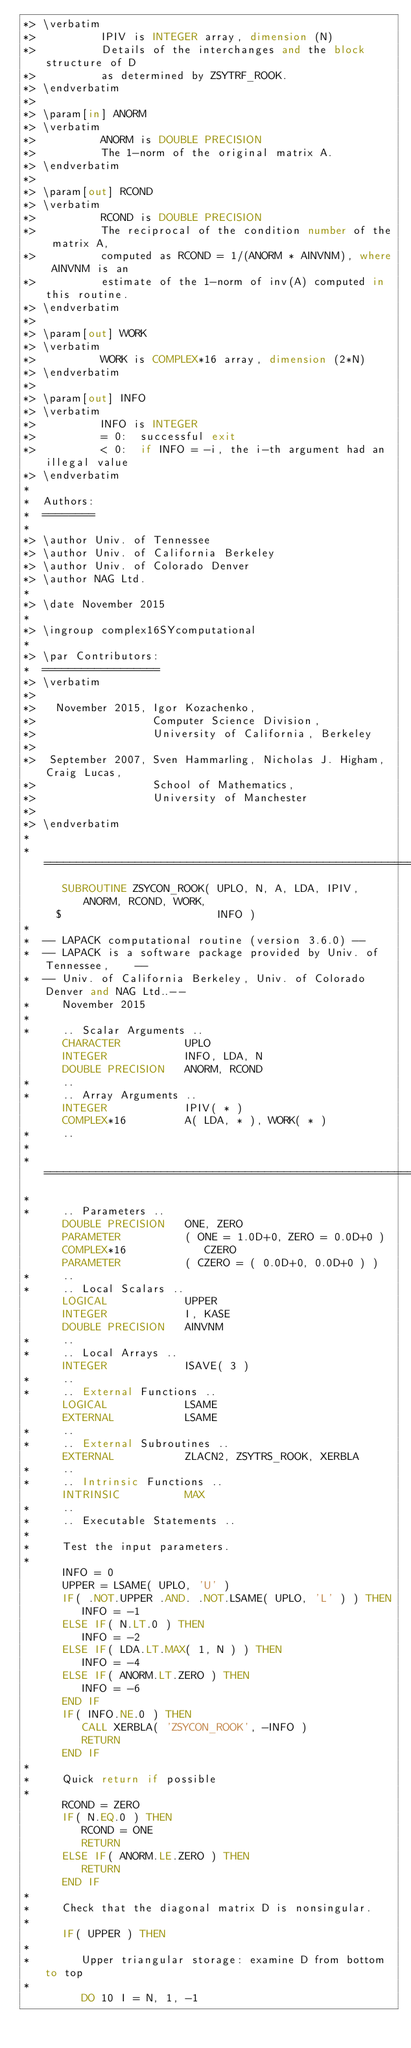<code> <loc_0><loc_0><loc_500><loc_500><_FORTRAN_>*> \verbatim
*>          IPIV is INTEGER array, dimension (N)
*>          Details of the interchanges and the block structure of D
*>          as determined by ZSYTRF_ROOK.
*> \endverbatim
*>
*> \param[in] ANORM
*> \verbatim
*>          ANORM is DOUBLE PRECISION
*>          The 1-norm of the original matrix A.
*> \endverbatim
*>
*> \param[out] RCOND
*> \verbatim
*>          RCOND is DOUBLE PRECISION
*>          The reciprocal of the condition number of the matrix A,
*>          computed as RCOND = 1/(ANORM * AINVNM), where AINVNM is an
*>          estimate of the 1-norm of inv(A) computed in this routine.
*> \endverbatim
*>
*> \param[out] WORK
*> \verbatim
*>          WORK is COMPLEX*16 array, dimension (2*N)
*> \endverbatim
*>
*> \param[out] INFO
*> \verbatim
*>          INFO is INTEGER
*>          = 0:  successful exit
*>          < 0:  if INFO = -i, the i-th argument had an illegal value
*> \endverbatim
*
*  Authors:
*  ========
*
*> \author Univ. of Tennessee 
*> \author Univ. of California Berkeley 
*> \author Univ. of Colorado Denver 
*> \author NAG Ltd. 
*
*> \date November 2015
*
*> \ingroup complex16SYcomputational
*
*> \par Contributors:
*  ==================
*> \verbatim
*>
*>   November 2015, Igor Kozachenko,
*>                  Computer Science Division,
*>                  University of California, Berkeley
*>
*>  September 2007, Sven Hammarling, Nicholas J. Higham, Craig Lucas,
*>                  School of Mathematics,
*>                  University of Manchester
*>
*> \endverbatim
*
*  =====================================================================
      SUBROUTINE ZSYCON_ROOK( UPLO, N, A, LDA, IPIV, ANORM, RCOND, WORK,
     $                        INFO )
*
*  -- LAPACK computational routine (version 3.6.0) --
*  -- LAPACK is a software package provided by Univ. of Tennessee,    --
*  -- Univ. of California Berkeley, Univ. of Colorado Denver and NAG Ltd..--
*     November 2015
*
*     .. Scalar Arguments ..
      CHARACTER          UPLO
      INTEGER            INFO, LDA, N
      DOUBLE PRECISION   ANORM, RCOND
*     ..
*     .. Array Arguments ..
      INTEGER            IPIV( * )
      COMPLEX*16         A( LDA, * ), WORK( * )
*     ..
*
*  =====================================================================
*
*     .. Parameters ..
      DOUBLE PRECISION   ONE, ZERO
      PARAMETER          ( ONE = 1.0D+0, ZERO = 0.0D+0 )
      COMPLEX*16            CZERO
      PARAMETER          ( CZERO = ( 0.0D+0, 0.0D+0 ) )
*     ..
*     .. Local Scalars ..
      LOGICAL            UPPER
      INTEGER            I, KASE
      DOUBLE PRECISION   AINVNM
*     ..
*     .. Local Arrays ..
      INTEGER            ISAVE( 3 )
*     ..
*     .. External Functions ..
      LOGICAL            LSAME
      EXTERNAL           LSAME
*     ..
*     .. External Subroutines ..
      EXTERNAL           ZLACN2, ZSYTRS_ROOK, XERBLA
*     ..
*     .. Intrinsic Functions ..
      INTRINSIC          MAX
*     ..
*     .. Executable Statements ..
*
*     Test the input parameters.
*
      INFO = 0
      UPPER = LSAME( UPLO, 'U' )
      IF( .NOT.UPPER .AND. .NOT.LSAME( UPLO, 'L' ) ) THEN
         INFO = -1
      ELSE IF( N.LT.0 ) THEN
         INFO = -2
      ELSE IF( LDA.LT.MAX( 1, N ) ) THEN
         INFO = -4
      ELSE IF( ANORM.LT.ZERO ) THEN
         INFO = -6
      END IF
      IF( INFO.NE.0 ) THEN
         CALL XERBLA( 'ZSYCON_ROOK', -INFO )
         RETURN
      END IF
*
*     Quick return if possible
*
      RCOND = ZERO
      IF( N.EQ.0 ) THEN
         RCOND = ONE
         RETURN
      ELSE IF( ANORM.LE.ZERO ) THEN
         RETURN
      END IF
*
*     Check that the diagonal matrix D is nonsingular.
*
      IF( UPPER ) THEN
*
*        Upper triangular storage: examine D from bottom to top
*
         DO 10 I = N, 1, -1</code> 